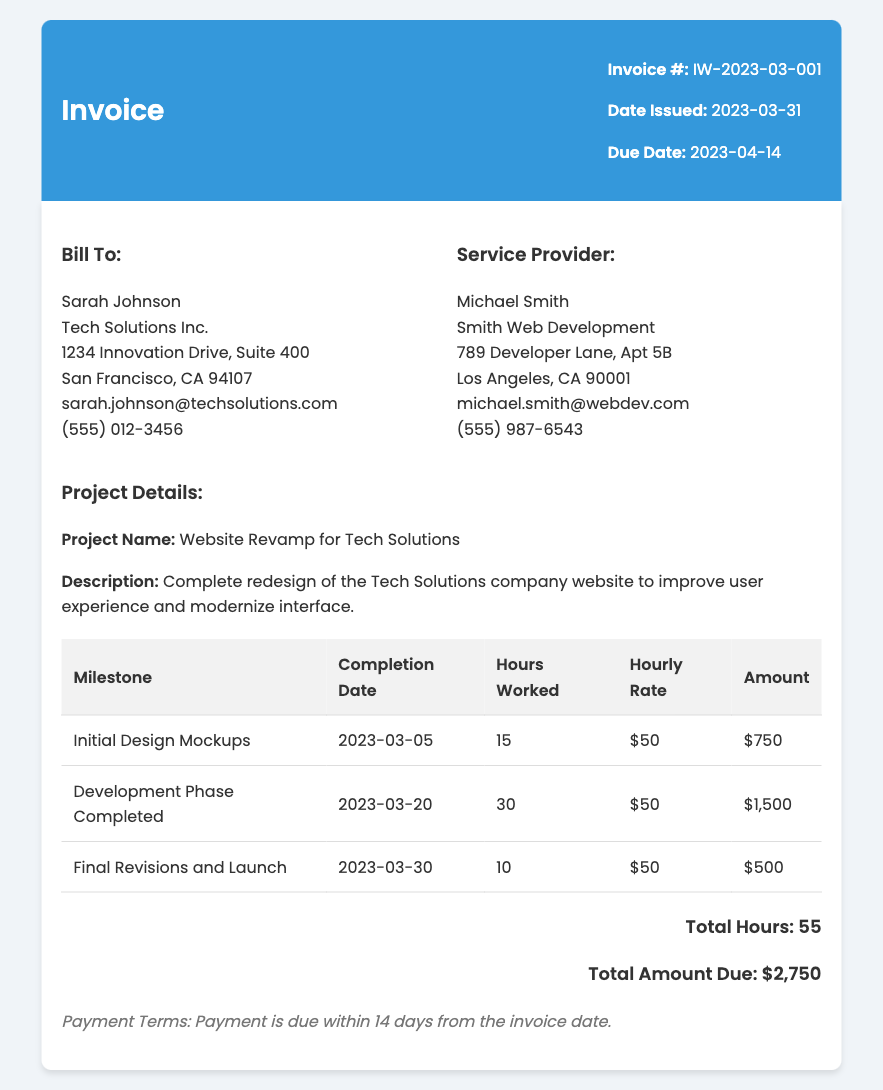What is the invoice number? The invoice number is located at the top of the document, specifically mentioned as 'Invoice #: IW-2023-03-001'.
Answer: IW-2023-03-001 Who is the service provider? The service provider's name is found in the 'Service Provider' section of the invoice and is listed as 'Michael Smith'.
Answer: Michael Smith What is the total amount due? The total amount due is highlighted in the 'total' section of the invoice and is stated as '$2,750'.
Answer: $2,750 How many hours were worked for the 'Development Phase Completed' milestone? The hours worked for the 'Development Phase Completed' milestone can be found in the table under the corresponding column and is noted as '30'.
Answer: 30 What is the due date for this invoice? The due date is specified near the top of the invoice under the 'Due Date' section as '2023-04-14'.
Answer: 2023-04-14 How many total hours were worked for the project? The total hours worked is summarized in the 'total' section of the invoice as '55'.
Answer: 55 What is the hourly rate charged? The hourly rate is mentioned in the milestone table under the 'Hourly Rate' column, which is '$50'.
Answer: $50 What is the payment term for this invoice? The payment terms are stated clearly at the bottom of the invoice, indicated as 'Payment is due within 14 days from the invoice date.'
Answer: 14 days 